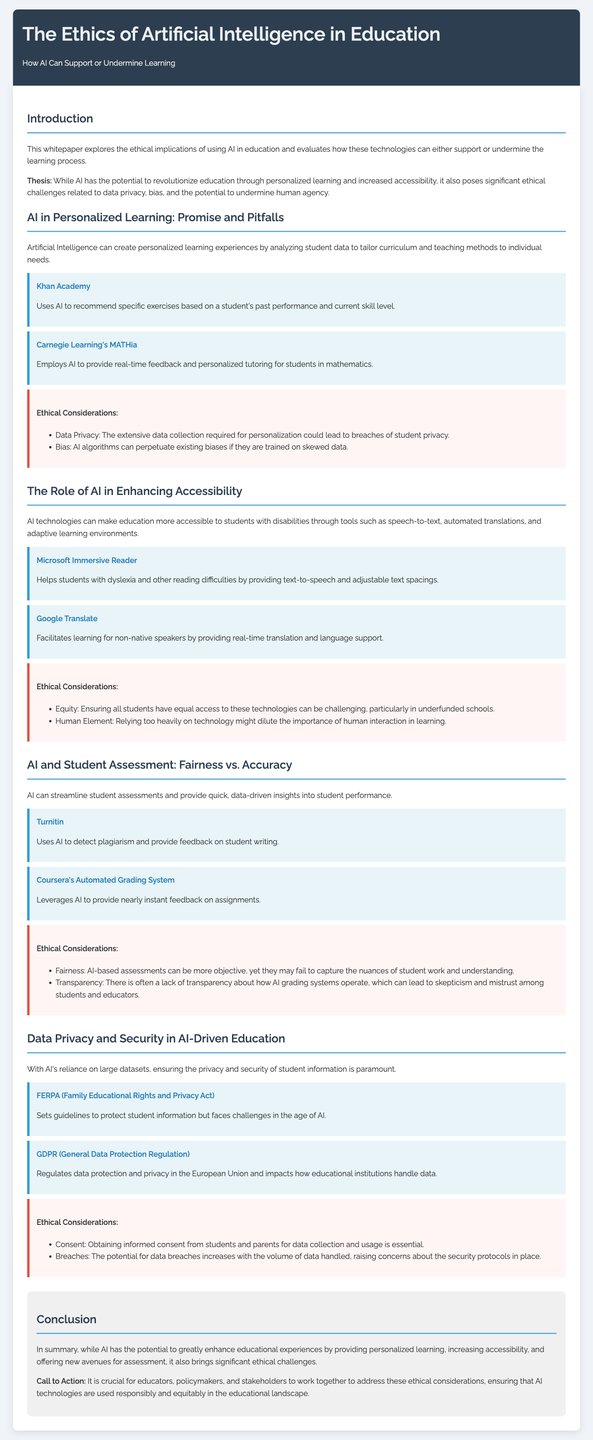What is the title of the whitepaper? The title of the whitepaper is prominently displayed at the top of the document, which summarizes the content.
Answer: The Ethics of Artificial Intelligence in Education What is the thesis statement? The thesis statement encapsulates the central argument of the whitepaper regarding AI in education.
Answer: AI has the potential to revolutionize education through personalized learning and increased accessibility What is one example of AI used for personalized learning? Examples provided in the document illustrate how AI can enhance personalized learning experiences.
Answer: Khan Academy What ethical consideration is mentioned regarding data privacy? The document lists specific ethical concerns associated with AI technologies, particularly related to data handling.
Answer: The extensive data collection required for personalization could lead to breaches of student privacy What is an example of an AI tool that enhances accessibility? The document offers practical examples of AI tools to assist students with disabilities.
Answer: Microsoft Immersive Reader How does AI impact student assessments according to the whitepaper? The whitepaper discusses both positive and negative effects of AI on the assessment process.
Answer: Streamline student assessments and provide quick, data-driven insights into student performance Which regulation addresses data privacy in education? The document highlights specific regulations that govern the handling of student data in educational contexts.
Answer: FERPA (Family Educational Rights and Privacy Act) What is a concern regarding the use of AI in grading? The document raises specific ethical concerns about AI's role in evaluating student work and assignments.
Answer: Lack of transparency about how AI grading systems operate What is the call to action in the conclusion? The conclusion includes a directive for stakeholders to engage with the ethical challenges presented by AI in education.
Answer: It is crucial for educators, policymakers, and stakeholders to work together to address these ethical considerations 